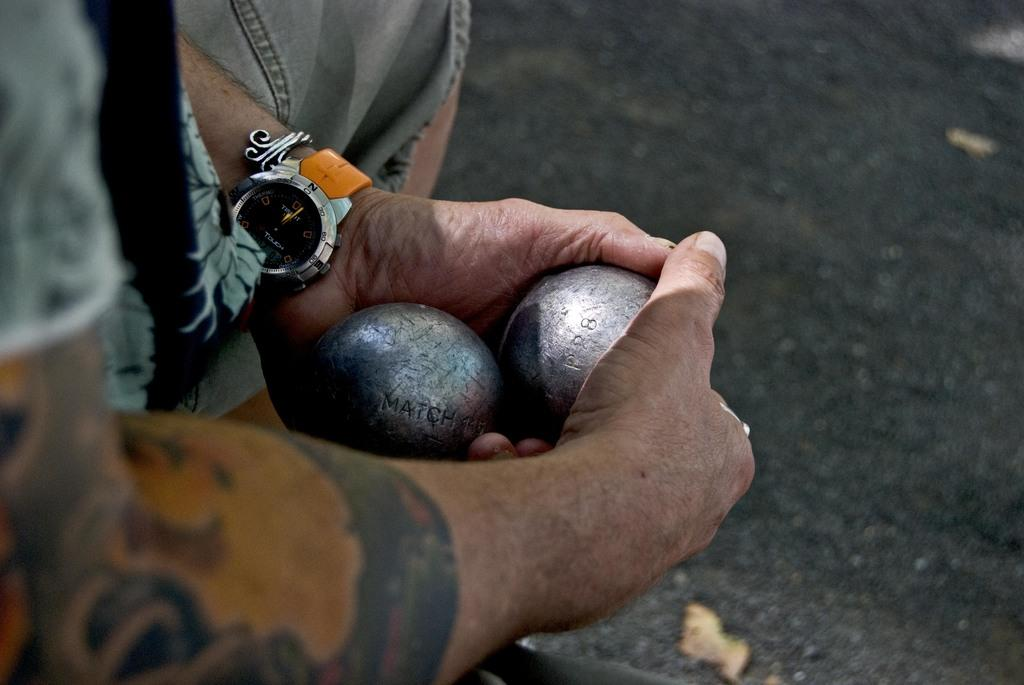<image>
Provide a brief description of the given image. A man wears a watch with the word "touch" on the face. 